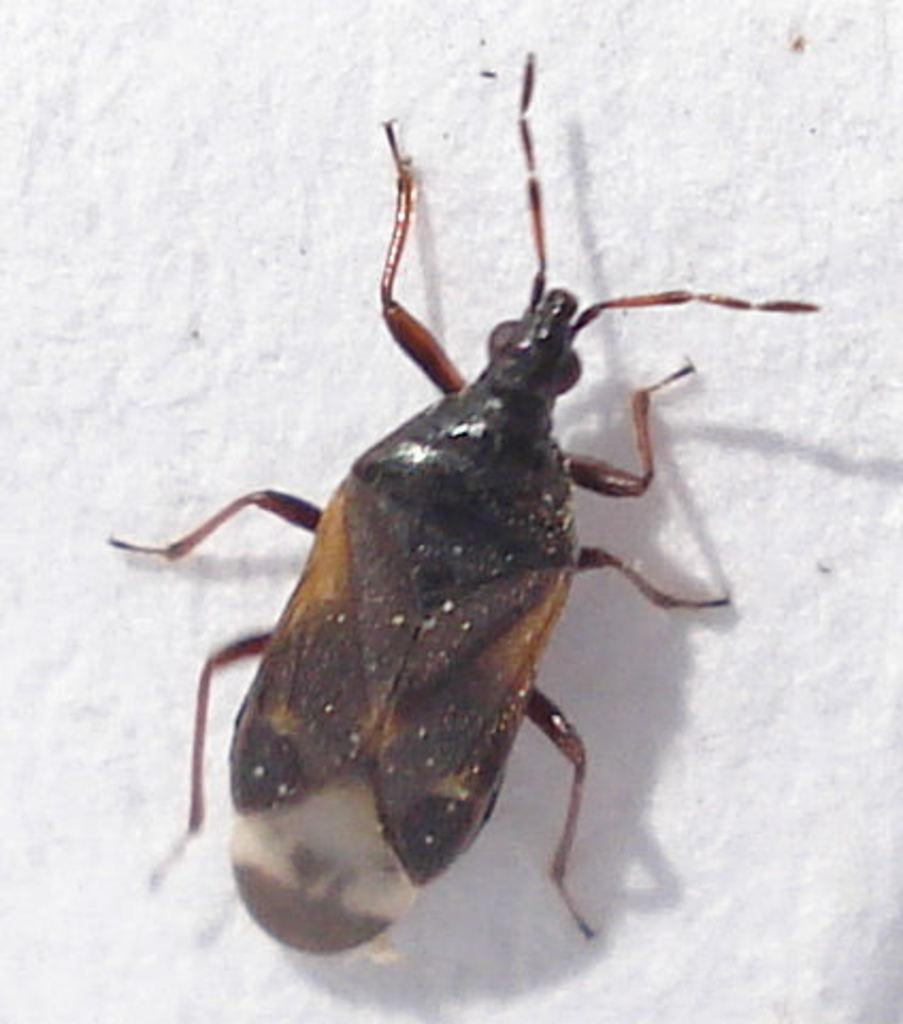What type of creature can be seen in the image? There is an insect in the image. What is visible in the background of the image? There appears to be a wall in the background of the image. Where is the father skateboarding on the dock in the image? There is no father, skateboarding, or dock present in the image; it only features an insect and a wall in the background. 